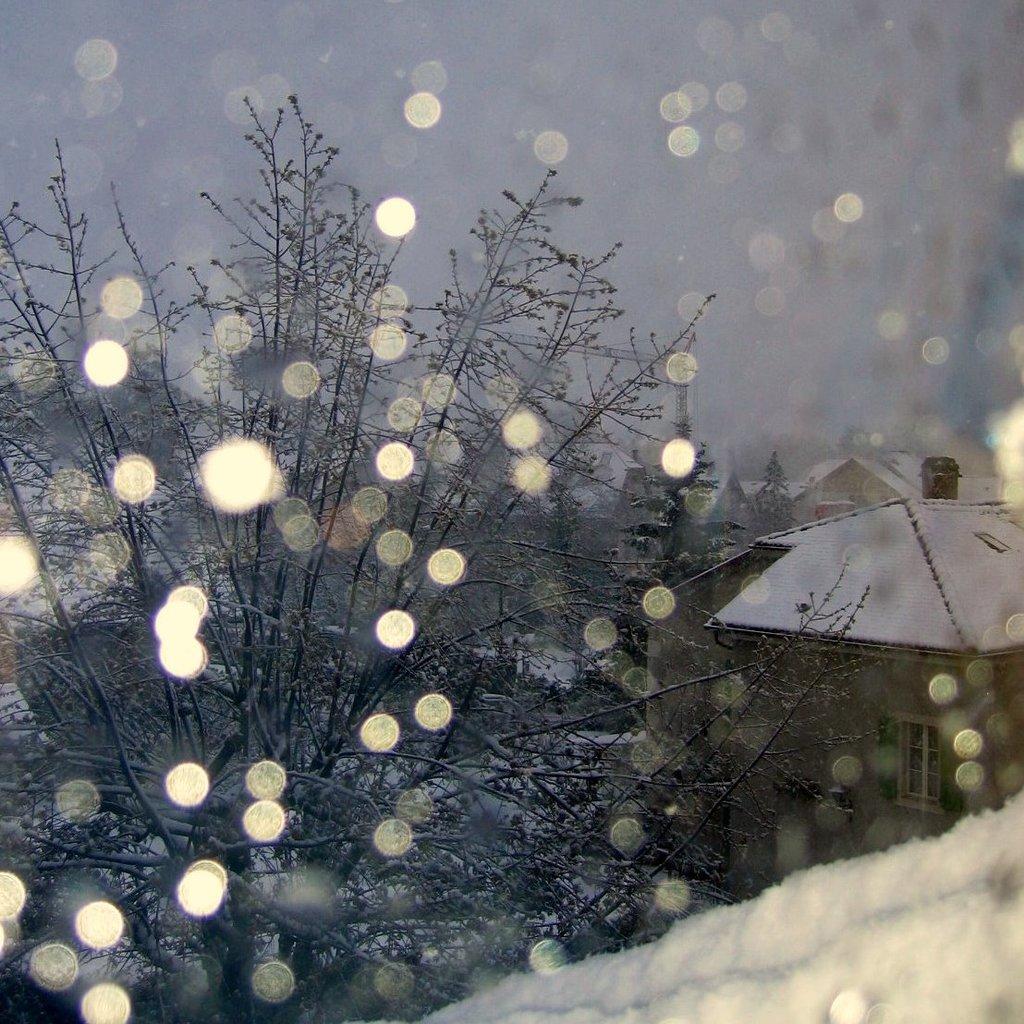Describe this image in one or two sentences. In this image we can see some snow, trees, houses and in the background of the image there is clear sky. 